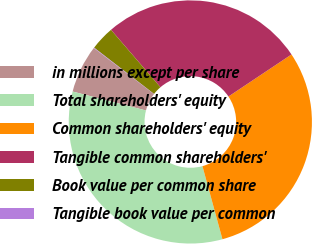Convert chart. <chart><loc_0><loc_0><loc_500><loc_500><pie_chart><fcel>in millions except per share<fcel>Total shareholders' equity<fcel>Common shareholders' equity<fcel>Tangible common shareholders'<fcel>Book value per common share<fcel>Tangible book value per common<nl><fcel>6.38%<fcel>33.28%<fcel>30.11%<fcel>26.95%<fcel>3.22%<fcel>0.06%<nl></chart> 